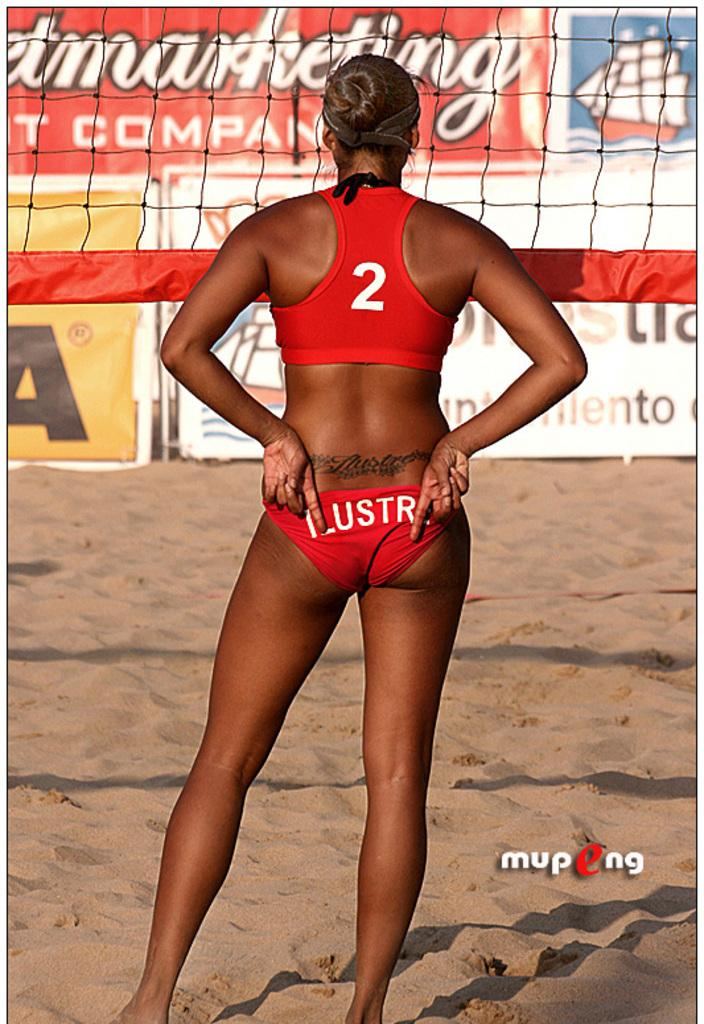<image>
Summarize the visual content of the image. The beach volleyball player displayed a tramp stamp and the number 2. 